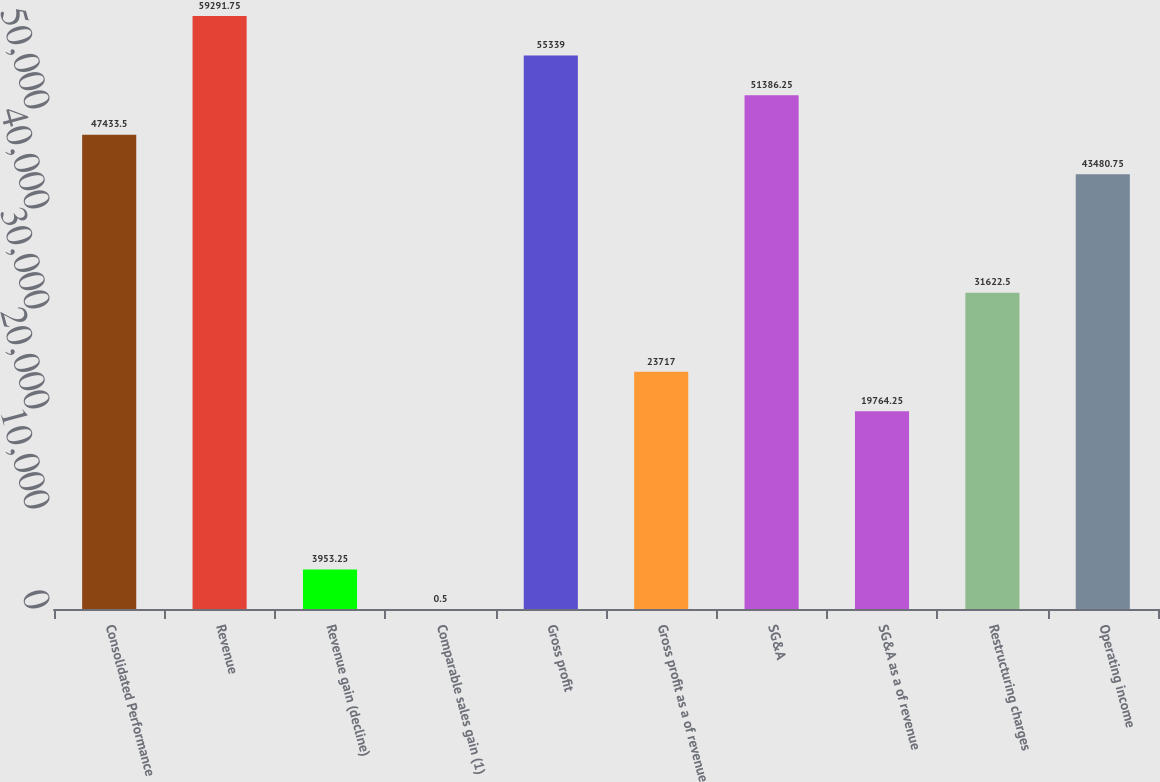Convert chart to OTSL. <chart><loc_0><loc_0><loc_500><loc_500><bar_chart><fcel>Consolidated Performance<fcel>Revenue<fcel>Revenue gain (decline)<fcel>Comparable sales gain (1)<fcel>Gross profit<fcel>Gross profit as a of revenue<fcel>SG&A<fcel>SG&A as a of revenue<fcel>Restructuring charges<fcel>Operating income<nl><fcel>47433.5<fcel>59291.8<fcel>3953.25<fcel>0.5<fcel>55339<fcel>23717<fcel>51386.2<fcel>19764.2<fcel>31622.5<fcel>43480.8<nl></chart> 